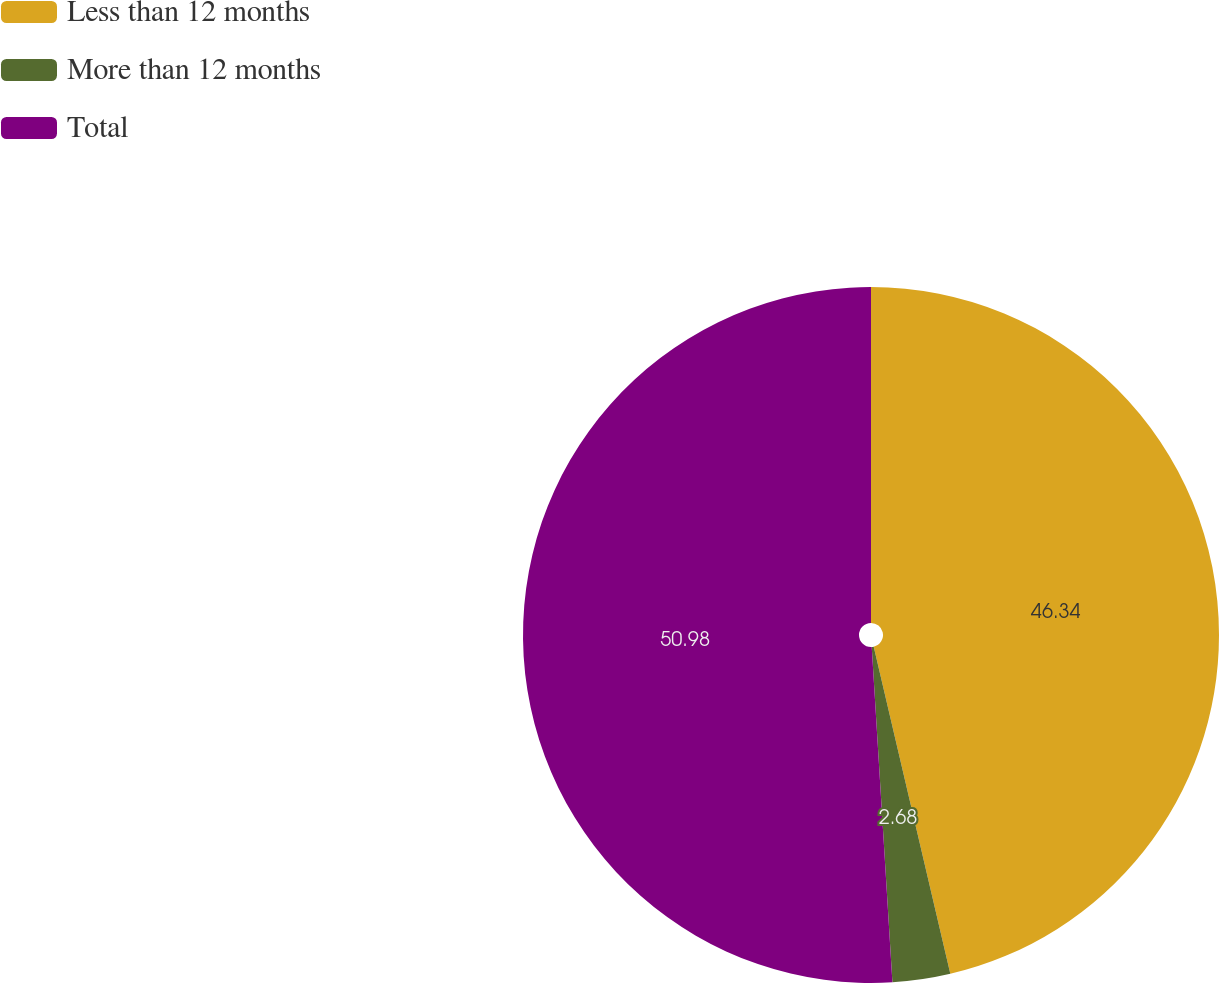<chart> <loc_0><loc_0><loc_500><loc_500><pie_chart><fcel>Less than 12 months<fcel>More than 12 months<fcel>Total<nl><fcel>46.34%<fcel>2.68%<fcel>50.98%<nl></chart> 